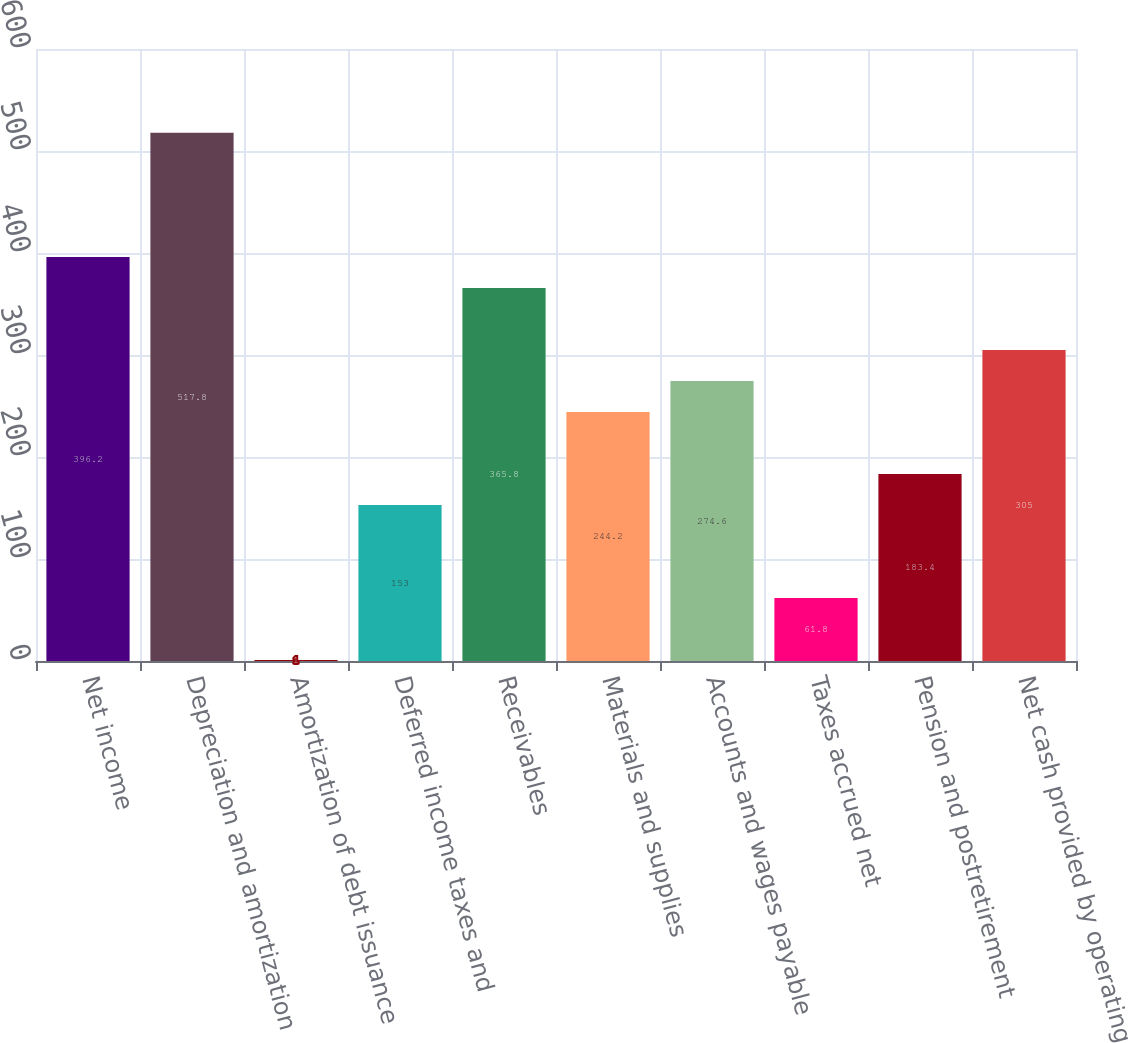Convert chart. <chart><loc_0><loc_0><loc_500><loc_500><bar_chart><fcel>Net income<fcel>Depreciation and amortization<fcel>Amortization of debt issuance<fcel>Deferred income taxes and<fcel>Receivables<fcel>Materials and supplies<fcel>Accounts and wages payable<fcel>Taxes accrued net<fcel>Pension and postretirement<fcel>Net cash provided by operating<nl><fcel>396.2<fcel>517.8<fcel>1<fcel>153<fcel>365.8<fcel>244.2<fcel>274.6<fcel>61.8<fcel>183.4<fcel>305<nl></chart> 